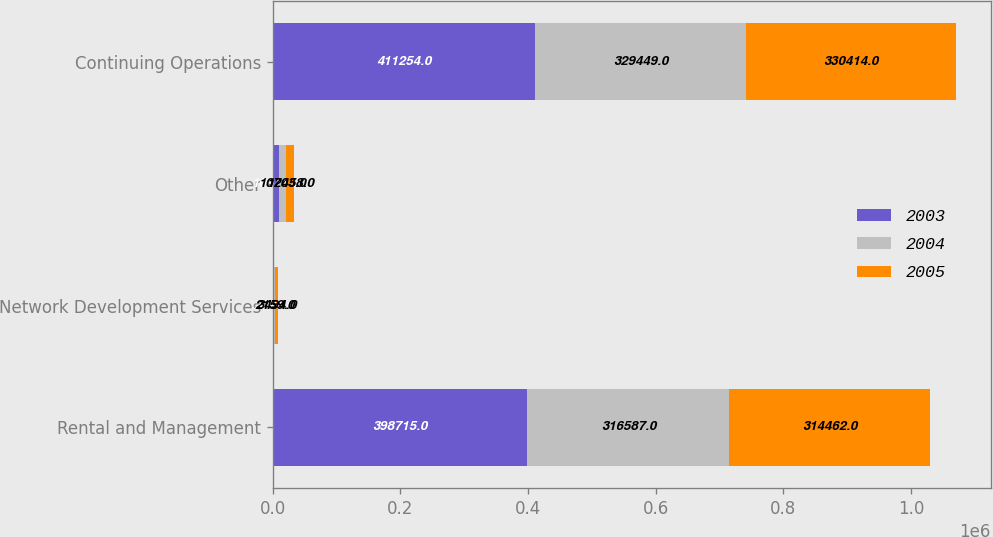Convert chart. <chart><loc_0><loc_0><loc_500><loc_500><stacked_bar_chart><ecel><fcel>Rental and Management<fcel>Network Development Services<fcel>Other<fcel>Continuing Operations<nl><fcel>2003<fcel>398715<fcel>2028<fcel>10511<fcel>411254<nl><fcel>2004<fcel>316587<fcel>2159<fcel>10703<fcel>329449<nl><fcel>2005<fcel>314462<fcel>3494<fcel>12458<fcel>330414<nl></chart> 